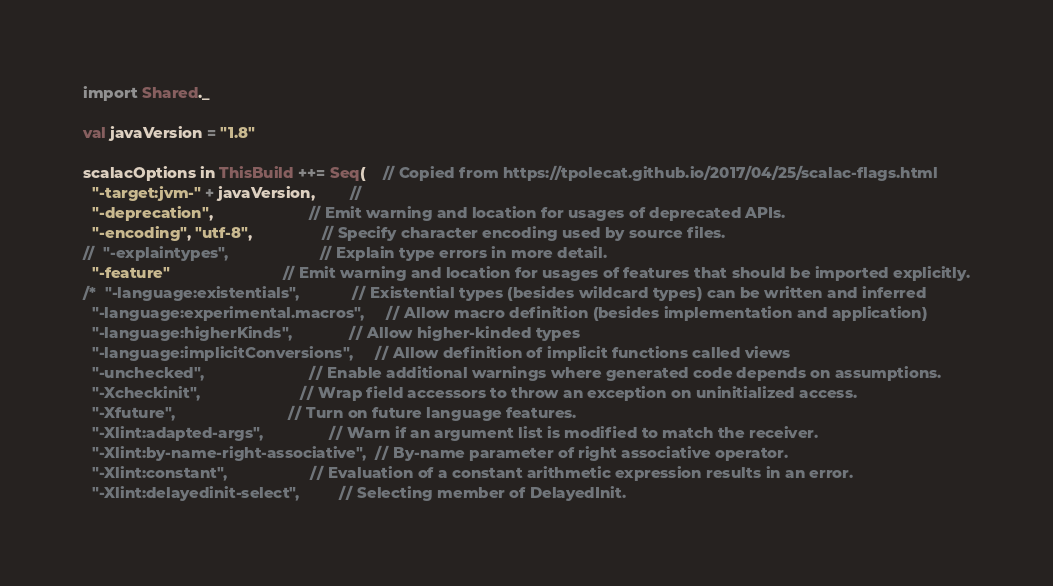Convert code to text. <code><loc_0><loc_0><loc_500><loc_500><_Scala_>import Shared._

val javaVersion = "1.8"

scalacOptions in ThisBuild ++= Seq(    // Copied from https://tpolecat.github.io/2017/04/25/scalac-flags.html
  "-target:jvm-" + javaVersion,        //
  "-deprecation",                      // Emit warning and location for usages of deprecated APIs.
  "-encoding", "utf-8",                // Specify character encoding used by source files.
//  "-explaintypes",                     // Explain type errors in more detail.
  "-feature"                          // Emit warning and location for usages of features that should be imported explicitly.
/*  "-language:existentials",            // Existential types (besides wildcard types) can be written and inferred
  "-language:experimental.macros",     // Allow macro definition (besides implementation and application)
  "-language:higherKinds",             // Allow higher-kinded types
  "-language:implicitConversions",     // Allow definition of implicit functions called views
  "-unchecked",                        // Enable additional warnings where generated code depends on assumptions.
  "-Xcheckinit",                       // Wrap field accessors to throw an exception on uninitialized access.
  "-Xfuture",                          // Turn on future language features.
  "-Xlint:adapted-args",               // Warn if an argument list is modified to match the receiver.
  "-Xlint:by-name-right-associative",  // By-name parameter of right associative operator.
  "-Xlint:constant",                   // Evaluation of a constant arithmetic expression results in an error.
  "-Xlint:delayedinit-select",         // Selecting member of DelayedInit.</code> 